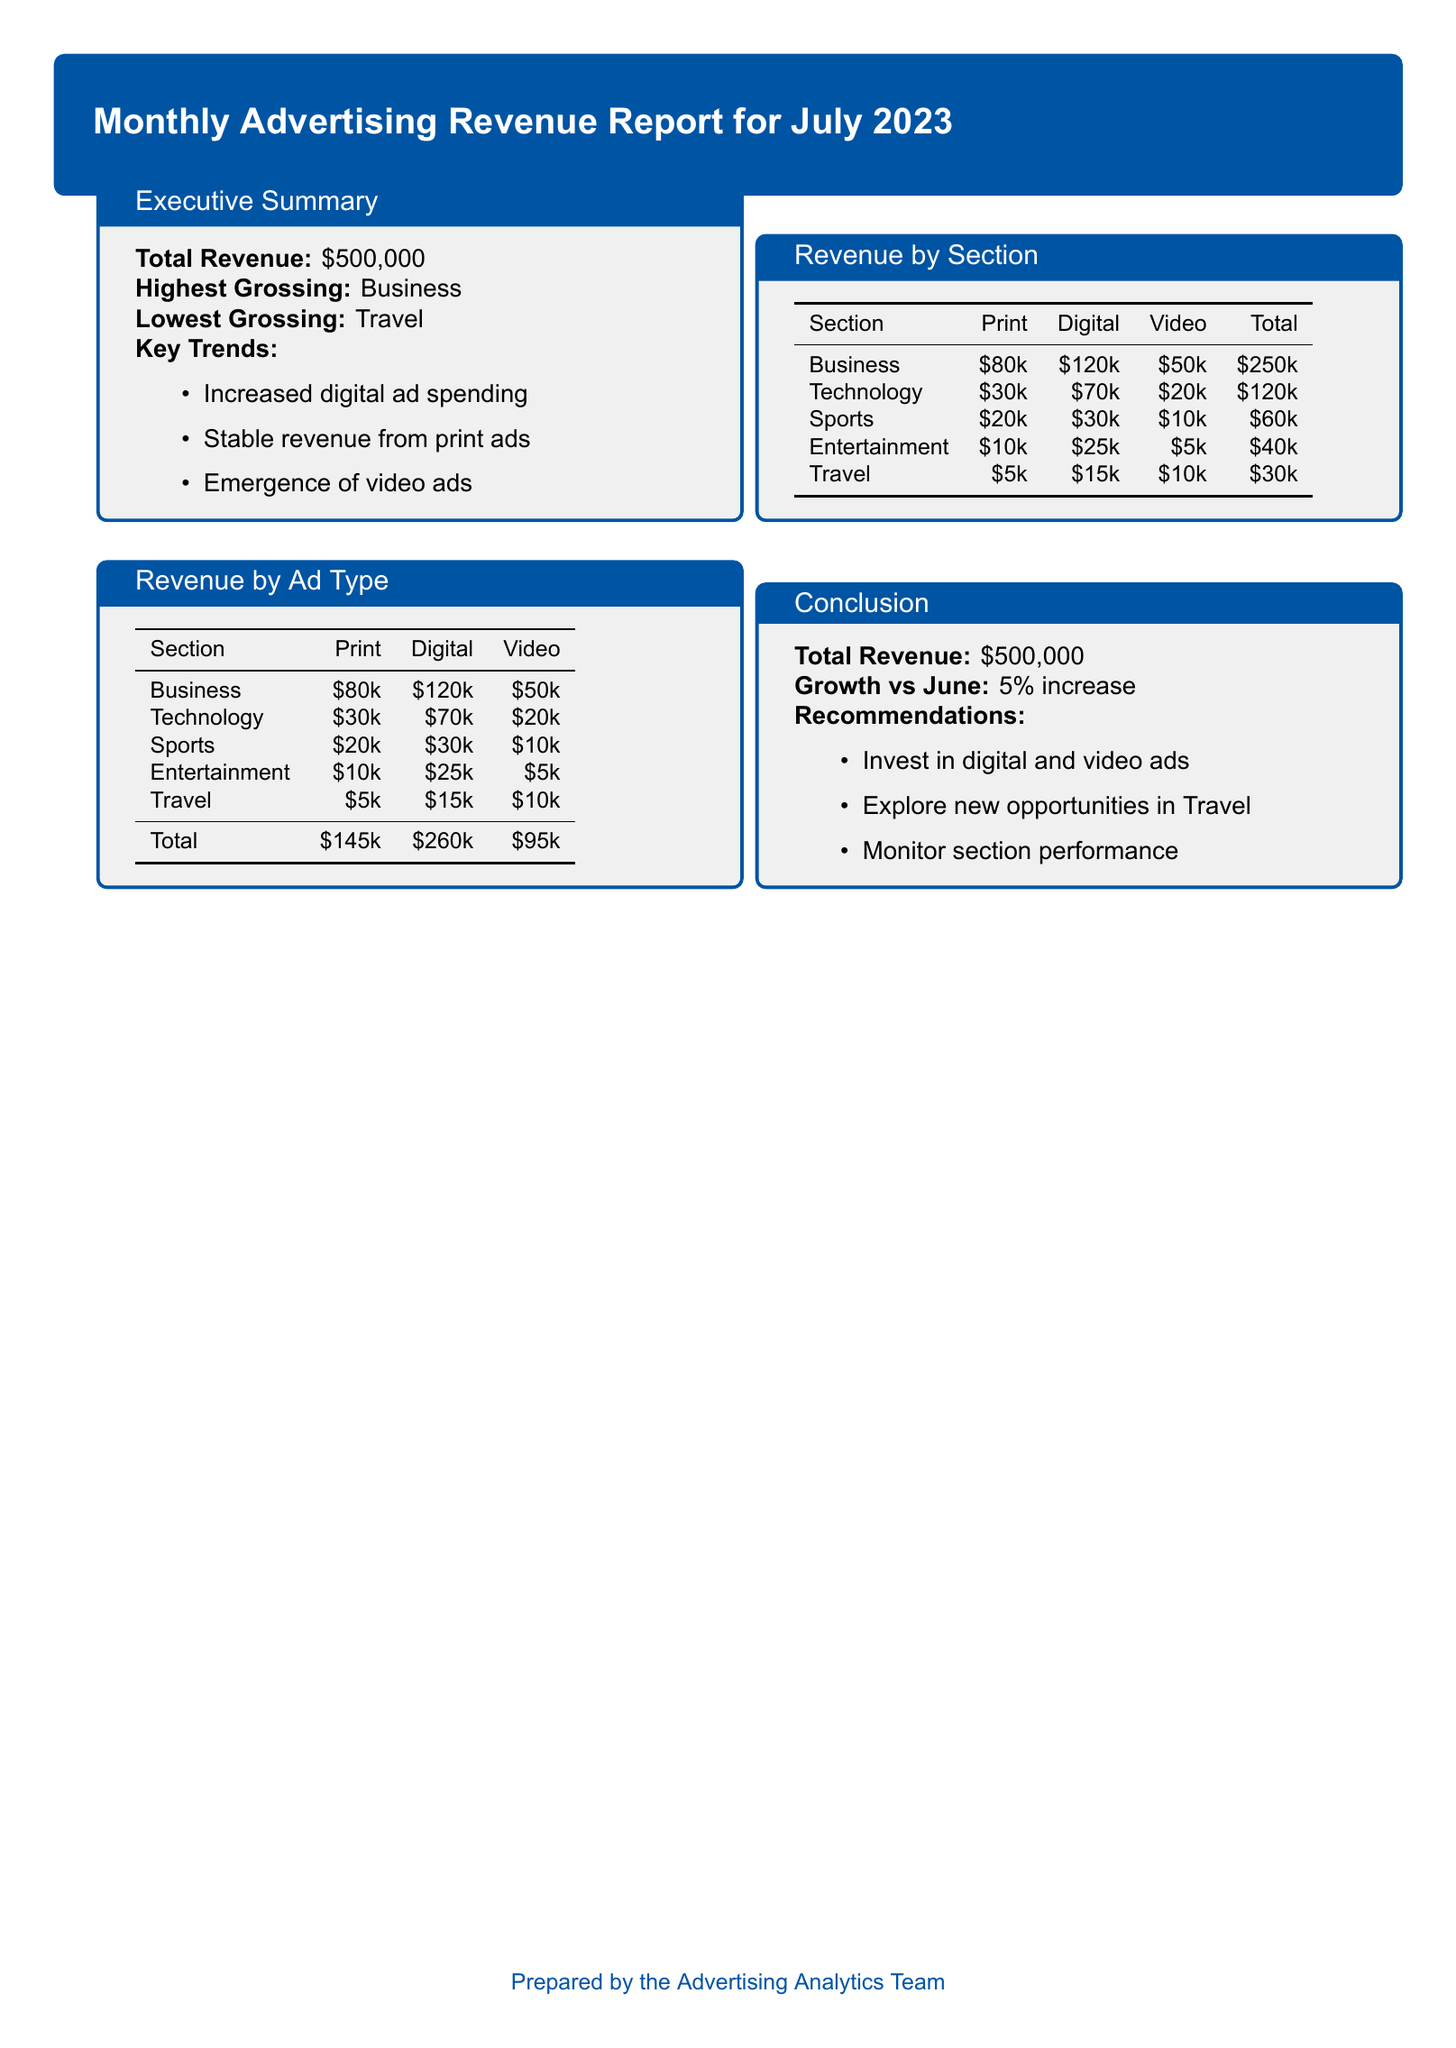What is the total revenue for July 2023? The total revenue is stated at the beginning of the document in the Executive Summary section.
Answer: $500,000 Which section generated the highest revenue? The Executive Summary mentions the highest grossing section, which is Business.
Answer: Business What was the lowest grossing section? According to the Executive Summary, the lowest grossing section is identified.
Answer: Travel How much revenue did digital ads generate? The total for digital revenue can be calculated by summing the digital revenue from each section listed in the Revenue by Ad Type table.
Answer: $260,000 What percentage increase in revenue was reported compared to June? The Conclusion section specifies the growth in revenue compared to June.
Answer: 5% Which section had the lowest revenue from print ads? The Revenue by Section breakdown table shows the print revenue for each section, with Travel having the lowest.
Answer: Travel How much revenue did video ads generate in total? The total revenue for video ads is provided in the Revenue by Ad Type table, combining the figures from all sections.
Answer: $95,000 What recommendations were made for advertising strategy? The Conclusion section lists specific recommendations for advertising based on the data, such as investing in certain ad types.
Answer: Invest in digital and video ads What amount of revenue did the Entertainment section earn from print ads? The Revenue by Section table specifies the print revenue for the Entertainment section.
Answer: $10k 